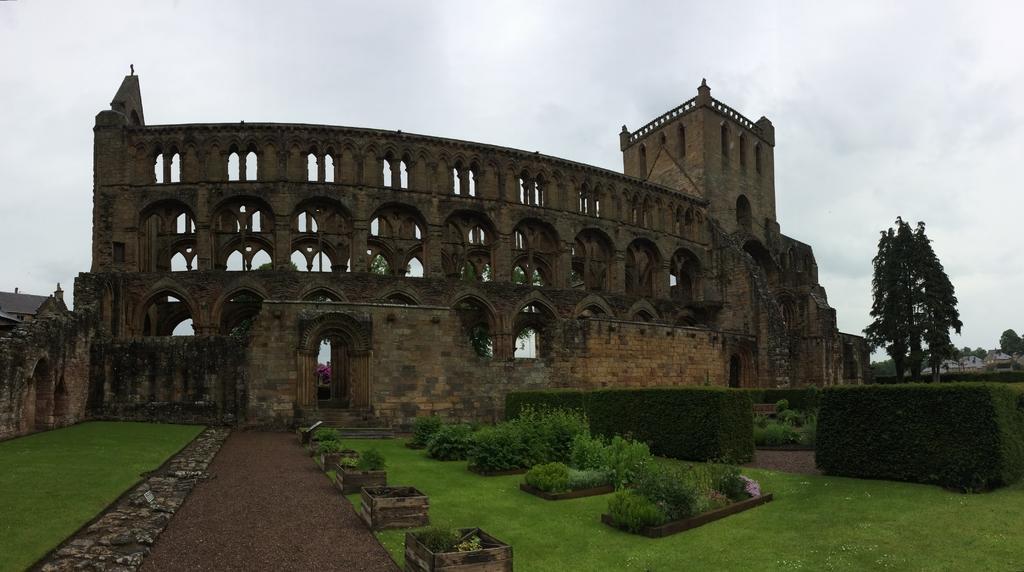Describe this image in one or two sentences. This image consists of a fort. In the front, there is a wall. At the bottom, there is a ground. To the right, there are trees. At the top, there are clouds in the sky. 